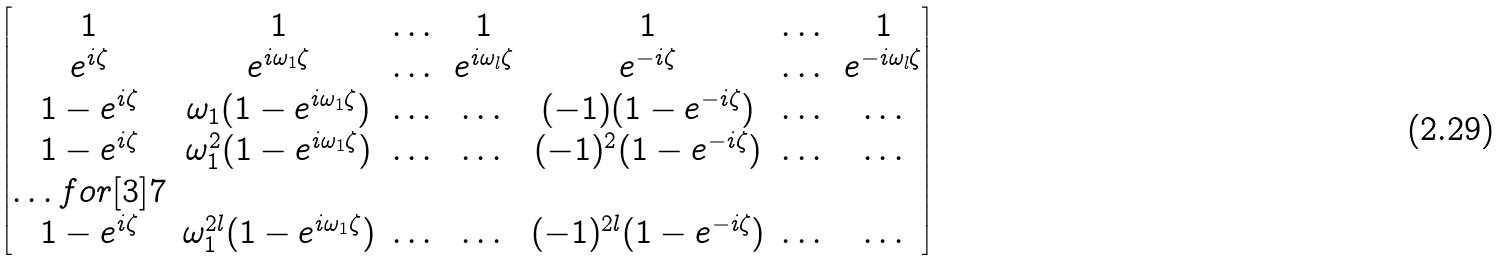<formula> <loc_0><loc_0><loc_500><loc_500>\begin{bmatrix} 1 & 1 & \dots & 1 & 1 & \dots & 1 \\ e ^ { i \zeta } & e ^ { i \omega _ { 1 } \zeta } & \dots & e ^ { i \omega _ { l } \zeta } & e ^ { - i \zeta } & \dots & e ^ { - i \omega _ { l } \zeta } \\ 1 - e ^ { i \zeta } & \omega _ { 1 } ( 1 - e ^ { i \omega _ { 1 } \zeta } ) & \dots & \dots & ( - 1 ) ( 1 - e ^ { - i \zeta } ) & \dots & \dots \\ 1 - e ^ { i \zeta } & \omega _ { 1 } ^ { 2 } ( 1 - e ^ { i \omega _ { 1 } \zeta } ) & \dots & \dots & ( - 1 ) ^ { 2 } ( 1 - e ^ { - i \zeta } ) & \dots & \dots \\ \hdots f o r [ 3 ] { 7 } \\ 1 - e ^ { i \zeta } & \omega _ { 1 } ^ { 2 l } ( 1 - e ^ { i \omega _ { 1 } \zeta } ) & \dots & \dots & ( - 1 ) ^ { 2 l } ( 1 - e ^ { - i \zeta } ) & \dots & \dots \\ \end{bmatrix}</formula> 